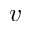Convert formula to latex. <formula><loc_0><loc_0><loc_500><loc_500>v</formula> 